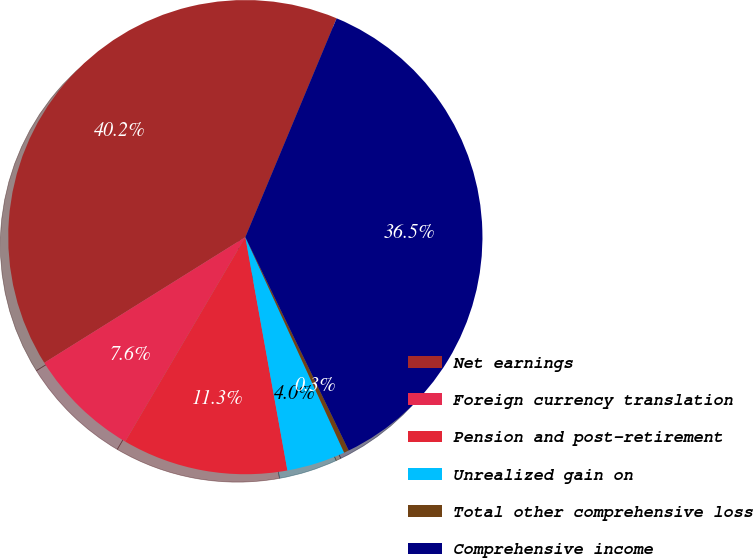<chart> <loc_0><loc_0><loc_500><loc_500><pie_chart><fcel>Net earnings<fcel>Foreign currency translation<fcel>Pension and post-retirement<fcel>Unrealized gain on<fcel>Total other comprehensive loss<fcel>Comprehensive income<nl><fcel>40.18%<fcel>7.65%<fcel>11.3%<fcel>4.0%<fcel>0.34%<fcel>36.53%<nl></chart> 